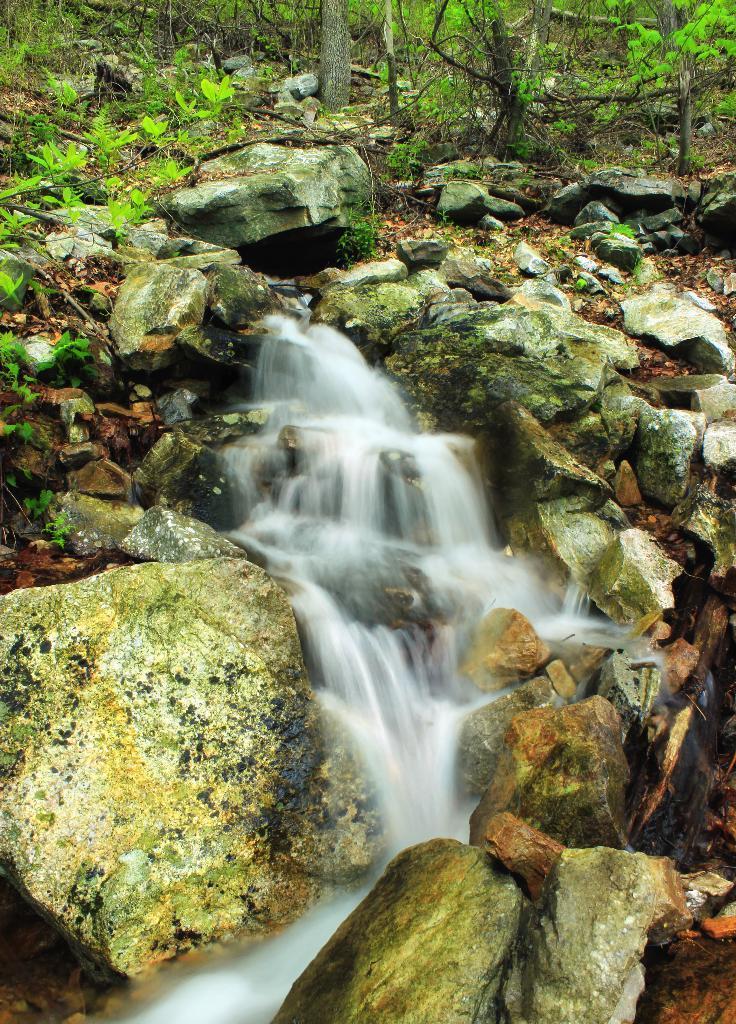Could you give a brief overview of what you see in this image? In this image there are few stones having some water fell on it. There are few plants, trees and few rocks are on the land. 